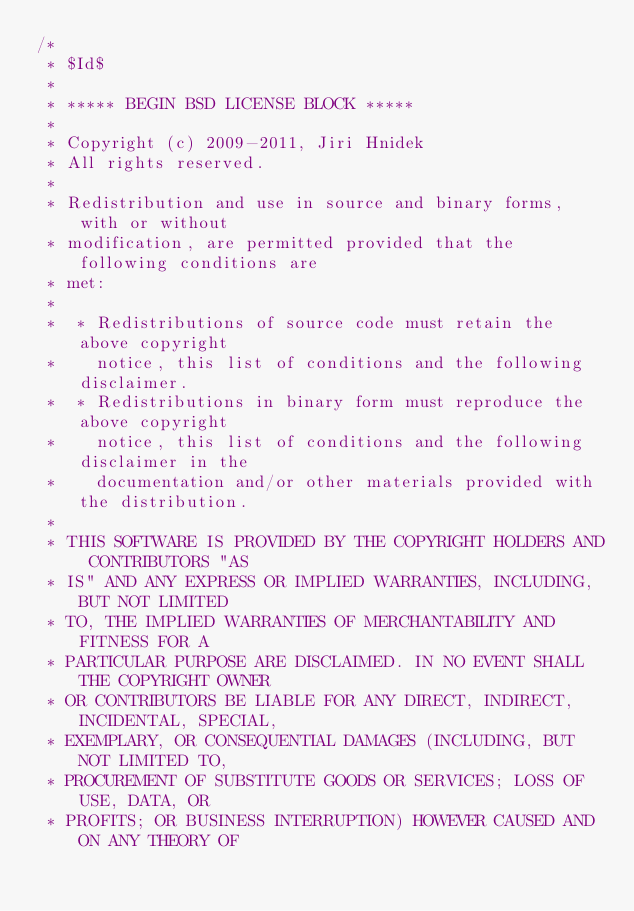Convert code to text. <code><loc_0><loc_0><loc_500><loc_500><_C_>/*
 * $Id$
 *
 * ***** BEGIN BSD LICENSE BLOCK *****
 *
 * Copyright (c) 2009-2011, Jiri Hnidek
 * All rights reserved.
 *
 * Redistribution and use in source and binary forms, with or without
 * modification, are permitted provided that the following conditions are
 * met:
 *
 *  * Redistributions of source code must retain the above copyright
 *    notice, this list of conditions and the following disclaimer.
 *  * Redistributions in binary form must reproduce the above copyright
 *    notice, this list of conditions and the following disclaimer in the
 *    documentation and/or other materials provided with the distribution.
 *
 * THIS SOFTWARE IS PROVIDED BY THE COPYRIGHT HOLDERS AND CONTRIBUTORS "AS
 * IS" AND ANY EXPRESS OR IMPLIED WARRANTIES, INCLUDING, BUT NOT LIMITED
 * TO, THE IMPLIED WARRANTIES OF MERCHANTABILITY AND FITNESS FOR A
 * PARTICULAR PURPOSE ARE DISCLAIMED. IN NO EVENT SHALL THE COPYRIGHT OWNER
 * OR CONTRIBUTORS BE LIABLE FOR ANY DIRECT, INDIRECT, INCIDENTAL, SPECIAL,
 * EXEMPLARY, OR CONSEQUENTIAL DAMAGES (INCLUDING, BUT NOT LIMITED TO,
 * PROCUREMENT OF SUBSTITUTE GOODS OR SERVICES; LOSS OF USE, DATA, OR
 * PROFITS; OR BUSINESS INTERRUPTION) HOWEVER CAUSED AND ON ANY THEORY OF</code> 